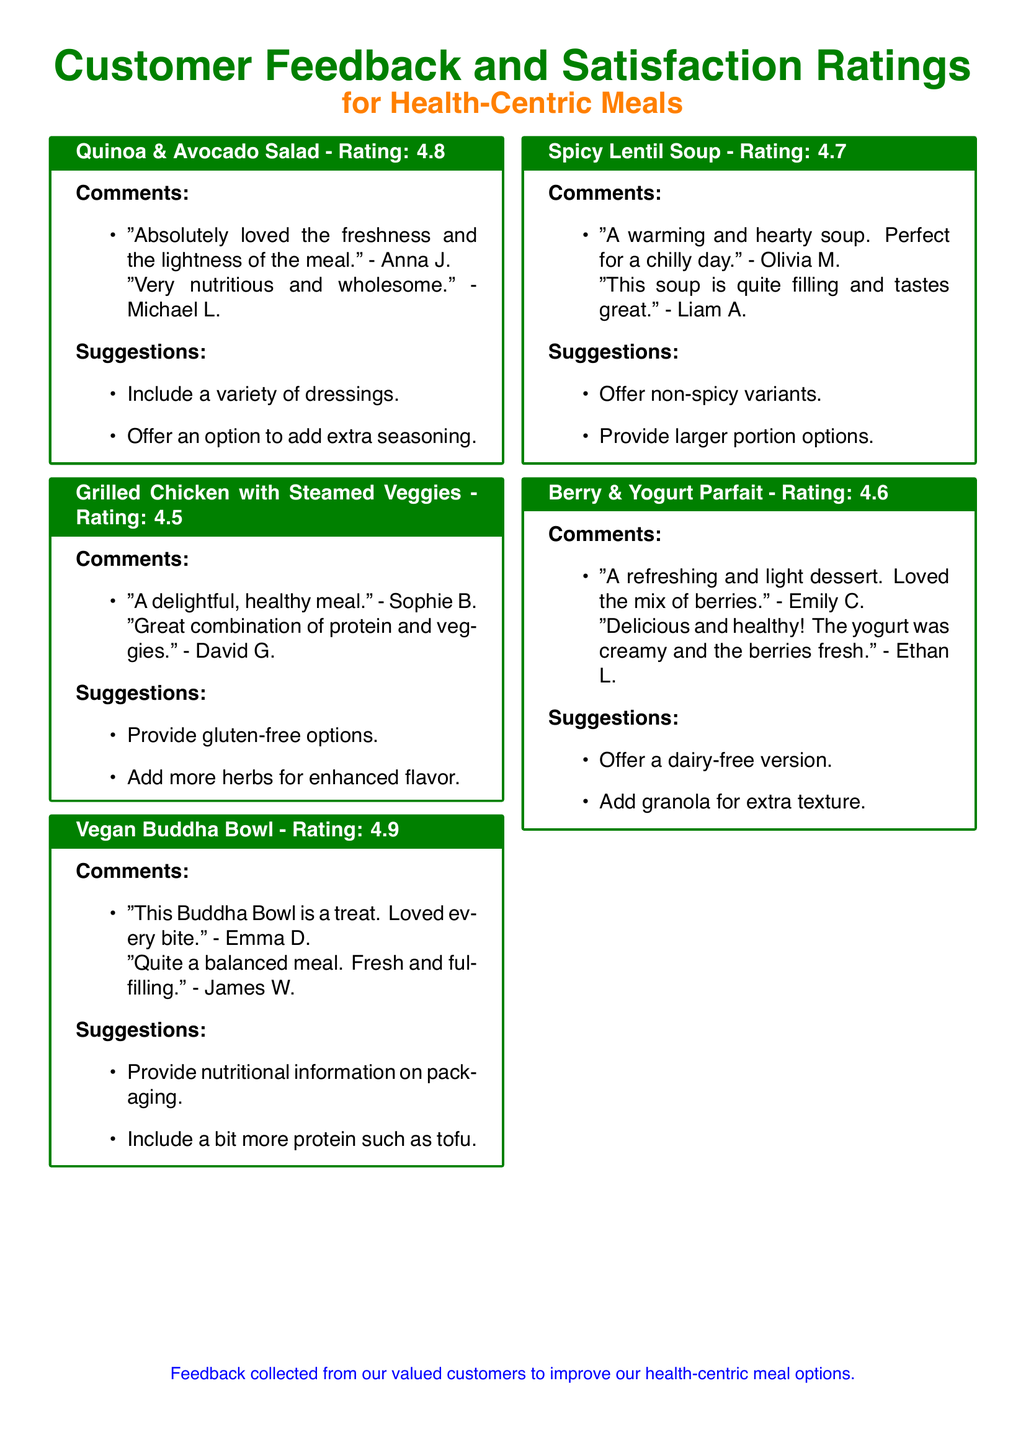What is the highest rating given to a meal? The highest rating in the document is found in the Vegan Buddha Bowl section, which has a rating of 4.9.
Answer: 4.9 Which meal received a suggestion to add more herbs? The suggestion for more herbs is mentioned in the Grilled Chicken with Steamed Veggies section.
Answer: Grilled Chicken with Steamed Veggies How many comments were provided for the Berry & Yogurt Parfait? The comments for the Berry & Yogurt Parfait section include two customer opinions.
Answer: 2 What type of meal is suggested to have a dairy-free version? The Berry & Yogurt Parfait is the meal suggested for a dairy-free option.
Answer: Berry & Yogurt Parfait Which meal was noted for being filling and great tasting? The Spicy Lentil Soup is noted for being filling and tasting great according to customer feedback.
Answer: Spicy Lentil Soup What is a suggestion for the Vegan Buddha Bowl? One suggestion for the Vegan Buddha Bowl is to provide nutritional information on packaging.
Answer: Provide nutritional information on packaging Which meal has comments mentioning freshness and lightness? The Quinoa & Avocado Salad is mentioned for its freshness and lightness in customer comments.
Answer: Quinoa & Avocado Salad What is the average rating of the meals listed? The ratings of the meals are 4.8, 4.5, 4.9, 4.7, and 4.6; the calculated average rating is (4.8 + 4.5 + 4.9 + 4.7 + 4.6) / 5 = 4.7.
Answer: 4.7 